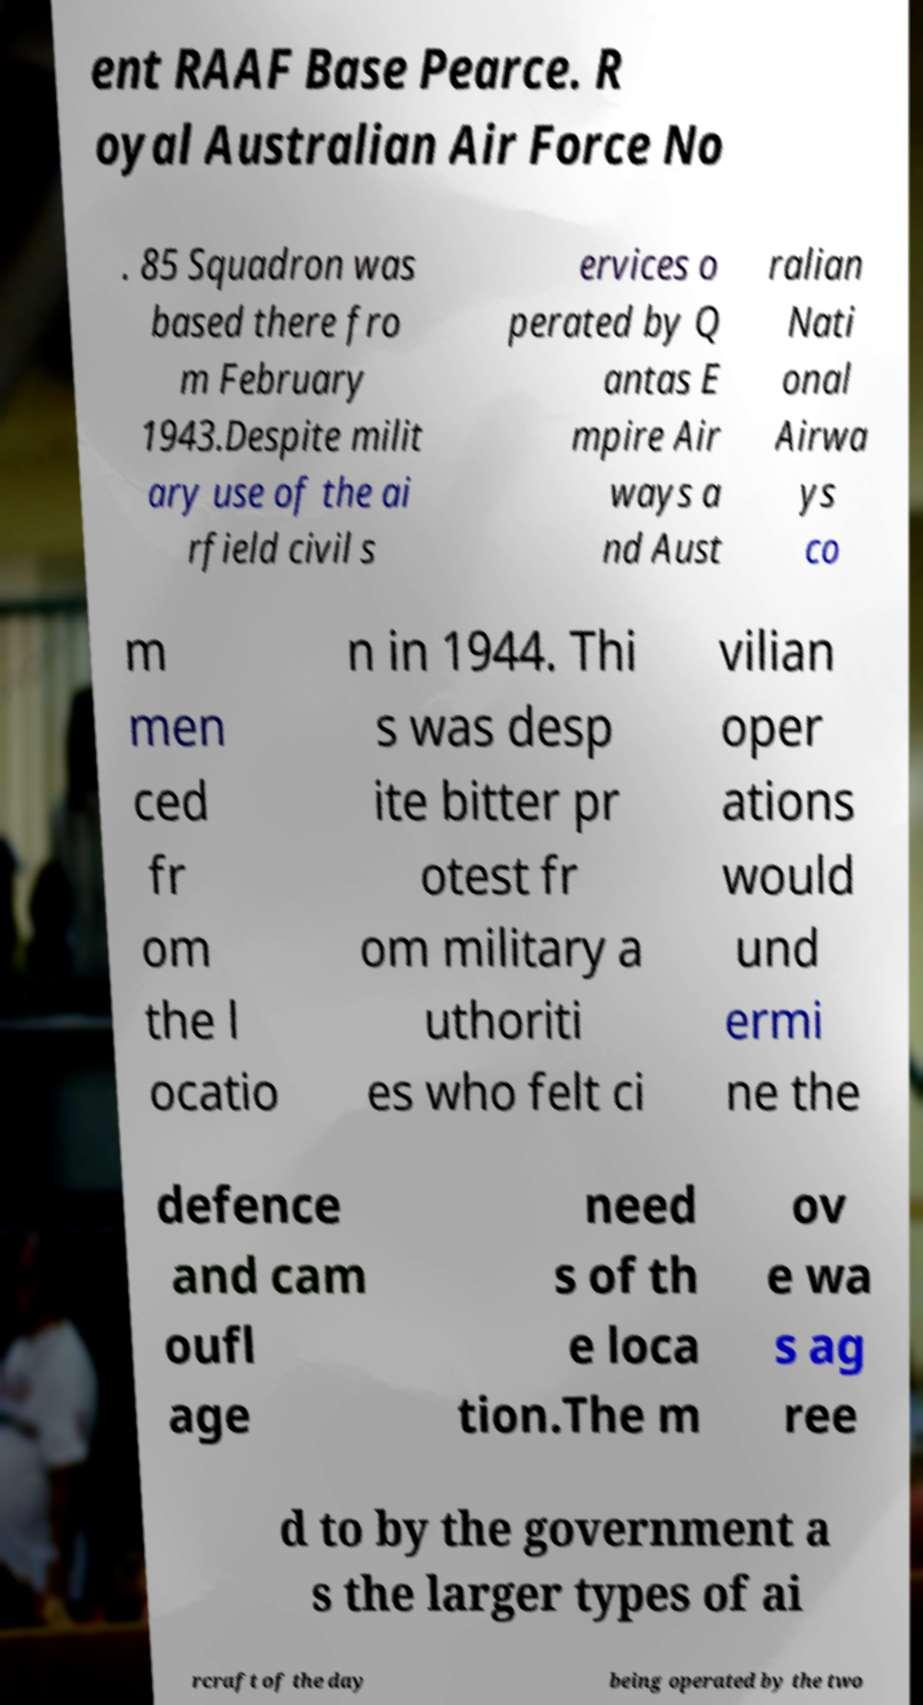There's text embedded in this image that I need extracted. Can you transcribe it verbatim? ent RAAF Base Pearce. R oyal Australian Air Force No . 85 Squadron was based there fro m February 1943.Despite milit ary use of the ai rfield civil s ervices o perated by Q antas E mpire Air ways a nd Aust ralian Nati onal Airwa ys co m men ced fr om the l ocatio n in 1944. Thi s was desp ite bitter pr otest fr om military a uthoriti es who felt ci vilian oper ations would und ermi ne the defence and cam oufl age need s of th e loca tion.The m ov e wa s ag ree d to by the government a s the larger types of ai rcraft of the day being operated by the two 